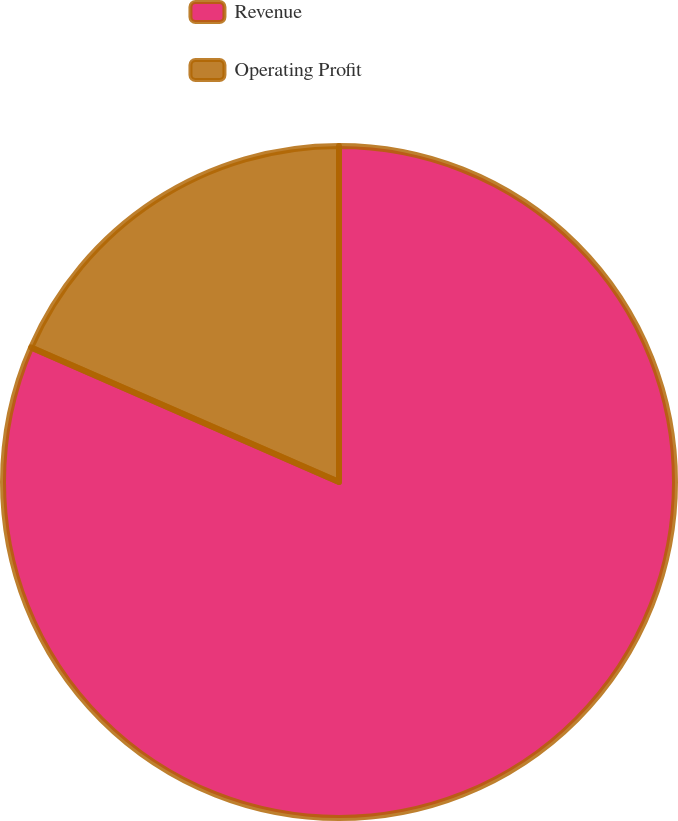<chart> <loc_0><loc_0><loc_500><loc_500><pie_chart><fcel>Revenue<fcel>Operating Profit<nl><fcel>81.56%<fcel>18.44%<nl></chart> 